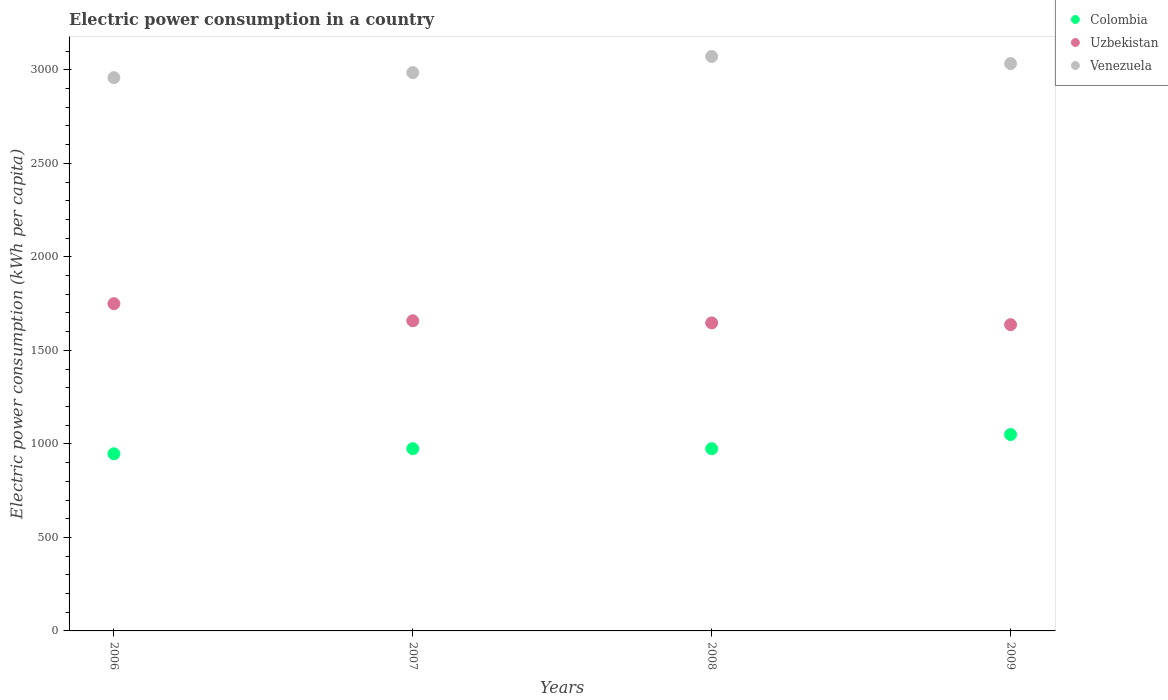How many different coloured dotlines are there?
Keep it short and to the point. 3. What is the electric power consumption in in Uzbekistan in 2009?
Make the answer very short. 1637.57. Across all years, what is the maximum electric power consumption in in Uzbekistan?
Provide a succinct answer. 1749.76. Across all years, what is the minimum electric power consumption in in Venezuela?
Keep it short and to the point. 2958.43. In which year was the electric power consumption in in Uzbekistan maximum?
Make the answer very short. 2006. What is the total electric power consumption in in Uzbekistan in the graph?
Ensure brevity in your answer.  6692.7. What is the difference between the electric power consumption in in Venezuela in 2007 and that in 2008?
Your answer should be compact. -86.19. What is the difference between the electric power consumption in in Colombia in 2007 and the electric power consumption in in Uzbekistan in 2008?
Provide a succinct answer. -672.63. What is the average electric power consumption in in Uzbekistan per year?
Provide a succinct answer. 1673.18. In the year 2007, what is the difference between the electric power consumption in in Uzbekistan and electric power consumption in in Colombia?
Provide a short and direct response. 683.98. In how many years, is the electric power consumption in in Venezuela greater than 400 kWh per capita?
Ensure brevity in your answer.  4. What is the ratio of the electric power consumption in in Colombia in 2007 to that in 2008?
Your answer should be very brief. 1. Is the difference between the electric power consumption in in Uzbekistan in 2006 and 2008 greater than the difference between the electric power consumption in in Colombia in 2006 and 2008?
Provide a short and direct response. Yes. What is the difference between the highest and the second highest electric power consumption in in Uzbekistan?
Your answer should be compact. 91.39. What is the difference between the highest and the lowest electric power consumption in in Colombia?
Offer a very short reply. 102.85. In how many years, is the electric power consumption in in Venezuela greater than the average electric power consumption in in Venezuela taken over all years?
Offer a very short reply. 2. Does the electric power consumption in in Uzbekistan monotonically increase over the years?
Offer a very short reply. No. Is the electric power consumption in in Uzbekistan strictly less than the electric power consumption in in Venezuela over the years?
Offer a very short reply. Yes. How many dotlines are there?
Make the answer very short. 3. What is the difference between two consecutive major ticks on the Y-axis?
Keep it short and to the point. 500. Are the values on the major ticks of Y-axis written in scientific E-notation?
Provide a succinct answer. No. Does the graph contain grids?
Offer a very short reply. No. Where does the legend appear in the graph?
Keep it short and to the point. Top right. What is the title of the graph?
Keep it short and to the point. Electric power consumption in a country. What is the label or title of the X-axis?
Offer a terse response. Years. What is the label or title of the Y-axis?
Provide a short and direct response. Electric power consumption (kWh per capita). What is the Electric power consumption (kWh per capita) of Colombia in 2006?
Your answer should be very brief. 947.13. What is the Electric power consumption (kWh per capita) of Uzbekistan in 2006?
Offer a very short reply. 1749.76. What is the Electric power consumption (kWh per capita) of Venezuela in 2006?
Offer a terse response. 2958.43. What is the Electric power consumption (kWh per capita) of Colombia in 2007?
Provide a short and direct response. 974.39. What is the Electric power consumption (kWh per capita) in Uzbekistan in 2007?
Provide a succinct answer. 1658.37. What is the Electric power consumption (kWh per capita) in Venezuela in 2007?
Give a very brief answer. 2985.62. What is the Electric power consumption (kWh per capita) in Colombia in 2008?
Provide a succinct answer. 974.22. What is the Electric power consumption (kWh per capita) of Uzbekistan in 2008?
Ensure brevity in your answer.  1647.01. What is the Electric power consumption (kWh per capita) of Venezuela in 2008?
Offer a very short reply. 3071.8. What is the Electric power consumption (kWh per capita) of Colombia in 2009?
Make the answer very short. 1049.98. What is the Electric power consumption (kWh per capita) of Uzbekistan in 2009?
Your response must be concise. 1637.57. What is the Electric power consumption (kWh per capita) in Venezuela in 2009?
Make the answer very short. 3033.87. Across all years, what is the maximum Electric power consumption (kWh per capita) in Colombia?
Give a very brief answer. 1049.98. Across all years, what is the maximum Electric power consumption (kWh per capita) of Uzbekistan?
Your answer should be compact. 1749.76. Across all years, what is the maximum Electric power consumption (kWh per capita) in Venezuela?
Your answer should be compact. 3071.8. Across all years, what is the minimum Electric power consumption (kWh per capita) in Colombia?
Your answer should be compact. 947.13. Across all years, what is the minimum Electric power consumption (kWh per capita) in Uzbekistan?
Provide a short and direct response. 1637.57. Across all years, what is the minimum Electric power consumption (kWh per capita) of Venezuela?
Provide a succinct answer. 2958.43. What is the total Electric power consumption (kWh per capita) of Colombia in the graph?
Your answer should be compact. 3945.71. What is the total Electric power consumption (kWh per capita) of Uzbekistan in the graph?
Ensure brevity in your answer.  6692.7. What is the total Electric power consumption (kWh per capita) in Venezuela in the graph?
Your response must be concise. 1.20e+04. What is the difference between the Electric power consumption (kWh per capita) in Colombia in 2006 and that in 2007?
Ensure brevity in your answer.  -27.26. What is the difference between the Electric power consumption (kWh per capita) in Uzbekistan in 2006 and that in 2007?
Ensure brevity in your answer.  91.39. What is the difference between the Electric power consumption (kWh per capita) in Venezuela in 2006 and that in 2007?
Provide a short and direct response. -27.19. What is the difference between the Electric power consumption (kWh per capita) in Colombia in 2006 and that in 2008?
Provide a short and direct response. -27.09. What is the difference between the Electric power consumption (kWh per capita) of Uzbekistan in 2006 and that in 2008?
Your answer should be very brief. 102.75. What is the difference between the Electric power consumption (kWh per capita) in Venezuela in 2006 and that in 2008?
Your answer should be compact. -113.38. What is the difference between the Electric power consumption (kWh per capita) in Colombia in 2006 and that in 2009?
Offer a terse response. -102.85. What is the difference between the Electric power consumption (kWh per capita) of Uzbekistan in 2006 and that in 2009?
Give a very brief answer. 112.19. What is the difference between the Electric power consumption (kWh per capita) in Venezuela in 2006 and that in 2009?
Ensure brevity in your answer.  -75.44. What is the difference between the Electric power consumption (kWh per capita) of Colombia in 2007 and that in 2008?
Offer a terse response. 0.17. What is the difference between the Electric power consumption (kWh per capita) of Uzbekistan in 2007 and that in 2008?
Give a very brief answer. 11.36. What is the difference between the Electric power consumption (kWh per capita) of Venezuela in 2007 and that in 2008?
Provide a short and direct response. -86.19. What is the difference between the Electric power consumption (kWh per capita) in Colombia in 2007 and that in 2009?
Your answer should be very brief. -75.59. What is the difference between the Electric power consumption (kWh per capita) in Uzbekistan in 2007 and that in 2009?
Keep it short and to the point. 20.8. What is the difference between the Electric power consumption (kWh per capita) of Venezuela in 2007 and that in 2009?
Provide a succinct answer. -48.25. What is the difference between the Electric power consumption (kWh per capita) of Colombia in 2008 and that in 2009?
Offer a terse response. -75.76. What is the difference between the Electric power consumption (kWh per capita) in Uzbekistan in 2008 and that in 2009?
Your response must be concise. 9.44. What is the difference between the Electric power consumption (kWh per capita) of Venezuela in 2008 and that in 2009?
Offer a very short reply. 37.94. What is the difference between the Electric power consumption (kWh per capita) in Colombia in 2006 and the Electric power consumption (kWh per capita) in Uzbekistan in 2007?
Keep it short and to the point. -711.24. What is the difference between the Electric power consumption (kWh per capita) of Colombia in 2006 and the Electric power consumption (kWh per capita) of Venezuela in 2007?
Your answer should be very brief. -2038.49. What is the difference between the Electric power consumption (kWh per capita) in Uzbekistan in 2006 and the Electric power consumption (kWh per capita) in Venezuela in 2007?
Give a very brief answer. -1235.86. What is the difference between the Electric power consumption (kWh per capita) of Colombia in 2006 and the Electric power consumption (kWh per capita) of Uzbekistan in 2008?
Provide a short and direct response. -699.88. What is the difference between the Electric power consumption (kWh per capita) in Colombia in 2006 and the Electric power consumption (kWh per capita) in Venezuela in 2008?
Give a very brief answer. -2124.68. What is the difference between the Electric power consumption (kWh per capita) of Uzbekistan in 2006 and the Electric power consumption (kWh per capita) of Venezuela in 2008?
Your answer should be compact. -1322.05. What is the difference between the Electric power consumption (kWh per capita) of Colombia in 2006 and the Electric power consumption (kWh per capita) of Uzbekistan in 2009?
Give a very brief answer. -690.44. What is the difference between the Electric power consumption (kWh per capita) of Colombia in 2006 and the Electric power consumption (kWh per capita) of Venezuela in 2009?
Your response must be concise. -2086.74. What is the difference between the Electric power consumption (kWh per capita) in Uzbekistan in 2006 and the Electric power consumption (kWh per capita) in Venezuela in 2009?
Provide a short and direct response. -1284.11. What is the difference between the Electric power consumption (kWh per capita) in Colombia in 2007 and the Electric power consumption (kWh per capita) in Uzbekistan in 2008?
Give a very brief answer. -672.63. What is the difference between the Electric power consumption (kWh per capita) of Colombia in 2007 and the Electric power consumption (kWh per capita) of Venezuela in 2008?
Your response must be concise. -2097.42. What is the difference between the Electric power consumption (kWh per capita) of Uzbekistan in 2007 and the Electric power consumption (kWh per capita) of Venezuela in 2008?
Provide a succinct answer. -1413.44. What is the difference between the Electric power consumption (kWh per capita) in Colombia in 2007 and the Electric power consumption (kWh per capita) in Uzbekistan in 2009?
Your answer should be compact. -663.18. What is the difference between the Electric power consumption (kWh per capita) in Colombia in 2007 and the Electric power consumption (kWh per capita) in Venezuela in 2009?
Your answer should be compact. -2059.48. What is the difference between the Electric power consumption (kWh per capita) in Uzbekistan in 2007 and the Electric power consumption (kWh per capita) in Venezuela in 2009?
Your answer should be very brief. -1375.5. What is the difference between the Electric power consumption (kWh per capita) in Colombia in 2008 and the Electric power consumption (kWh per capita) in Uzbekistan in 2009?
Ensure brevity in your answer.  -663.35. What is the difference between the Electric power consumption (kWh per capita) in Colombia in 2008 and the Electric power consumption (kWh per capita) in Venezuela in 2009?
Provide a succinct answer. -2059.65. What is the difference between the Electric power consumption (kWh per capita) in Uzbekistan in 2008 and the Electric power consumption (kWh per capita) in Venezuela in 2009?
Your answer should be very brief. -1386.86. What is the average Electric power consumption (kWh per capita) of Colombia per year?
Provide a short and direct response. 986.43. What is the average Electric power consumption (kWh per capita) in Uzbekistan per year?
Keep it short and to the point. 1673.18. What is the average Electric power consumption (kWh per capita) in Venezuela per year?
Offer a very short reply. 3012.43. In the year 2006, what is the difference between the Electric power consumption (kWh per capita) in Colombia and Electric power consumption (kWh per capita) in Uzbekistan?
Ensure brevity in your answer.  -802.63. In the year 2006, what is the difference between the Electric power consumption (kWh per capita) of Colombia and Electric power consumption (kWh per capita) of Venezuela?
Keep it short and to the point. -2011.3. In the year 2006, what is the difference between the Electric power consumption (kWh per capita) in Uzbekistan and Electric power consumption (kWh per capita) in Venezuela?
Your answer should be very brief. -1208.67. In the year 2007, what is the difference between the Electric power consumption (kWh per capita) in Colombia and Electric power consumption (kWh per capita) in Uzbekistan?
Ensure brevity in your answer.  -683.98. In the year 2007, what is the difference between the Electric power consumption (kWh per capita) in Colombia and Electric power consumption (kWh per capita) in Venezuela?
Your answer should be very brief. -2011.23. In the year 2007, what is the difference between the Electric power consumption (kWh per capita) in Uzbekistan and Electric power consumption (kWh per capita) in Venezuela?
Provide a short and direct response. -1327.25. In the year 2008, what is the difference between the Electric power consumption (kWh per capita) of Colombia and Electric power consumption (kWh per capita) of Uzbekistan?
Keep it short and to the point. -672.79. In the year 2008, what is the difference between the Electric power consumption (kWh per capita) in Colombia and Electric power consumption (kWh per capita) in Venezuela?
Your answer should be very brief. -2097.58. In the year 2008, what is the difference between the Electric power consumption (kWh per capita) in Uzbekistan and Electric power consumption (kWh per capita) in Venezuela?
Offer a terse response. -1424.79. In the year 2009, what is the difference between the Electric power consumption (kWh per capita) of Colombia and Electric power consumption (kWh per capita) of Uzbekistan?
Your answer should be very brief. -587.59. In the year 2009, what is the difference between the Electric power consumption (kWh per capita) in Colombia and Electric power consumption (kWh per capita) in Venezuela?
Provide a short and direct response. -1983.89. In the year 2009, what is the difference between the Electric power consumption (kWh per capita) of Uzbekistan and Electric power consumption (kWh per capita) of Venezuela?
Your response must be concise. -1396.3. What is the ratio of the Electric power consumption (kWh per capita) of Colombia in 2006 to that in 2007?
Provide a succinct answer. 0.97. What is the ratio of the Electric power consumption (kWh per capita) of Uzbekistan in 2006 to that in 2007?
Provide a short and direct response. 1.06. What is the ratio of the Electric power consumption (kWh per capita) of Venezuela in 2006 to that in 2007?
Make the answer very short. 0.99. What is the ratio of the Electric power consumption (kWh per capita) in Colombia in 2006 to that in 2008?
Offer a very short reply. 0.97. What is the ratio of the Electric power consumption (kWh per capita) of Uzbekistan in 2006 to that in 2008?
Your response must be concise. 1.06. What is the ratio of the Electric power consumption (kWh per capita) of Venezuela in 2006 to that in 2008?
Give a very brief answer. 0.96. What is the ratio of the Electric power consumption (kWh per capita) of Colombia in 2006 to that in 2009?
Offer a very short reply. 0.9. What is the ratio of the Electric power consumption (kWh per capita) of Uzbekistan in 2006 to that in 2009?
Give a very brief answer. 1.07. What is the ratio of the Electric power consumption (kWh per capita) in Venezuela in 2006 to that in 2009?
Your answer should be very brief. 0.98. What is the ratio of the Electric power consumption (kWh per capita) in Colombia in 2007 to that in 2008?
Your answer should be compact. 1. What is the ratio of the Electric power consumption (kWh per capita) in Uzbekistan in 2007 to that in 2008?
Offer a terse response. 1.01. What is the ratio of the Electric power consumption (kWh per capita) of Venezuela in 2007 to that in 2008?
Keep it short and to the point. 0.97. What is the ratio of the Electric power consumption (kWh per capita) of Colombia in 2007 to that in 2009?
Offer a terse response. 0.93. What is the ratio of the Electric power consumption (kWh per capita) in Uzbekistan in 2007 to that in 2009?
Provide a succinct answer. 1.01. What is the ratio of the Electric power consumption (kWh per capita) of Venezuela in 2007 to that in 2009?
Provide a short and direct response. 0.98. What is the ratio of the Electric power consumption (kWh per capita) in Colombia in 2008 to that in 2009?
Ensure brevity in your answer.  0.93. What is the ratio of the Electric power consumption (kWh per capita) of Venezuela in 2008 to that in 2009?
Your response must be concise. 1.01. What is the difference between the highest and the second highest Electric power consumption (kWh per capita) of Colombia?
Your answer should be compact. 75.59. What is the difference between the highest and the second highest Electric power consumption (kWh per capita) of Uzbekistan?
Ensure brevity in your answer.  91.39. What is the difference between the highest and the second highest Electric power consumption (kWh per capita) in Venezuela?
Your answer should be compact. 37.94. What is the difference between the highest and the lowest Electric power consumption (kWh per capita) in Colombia?
Keep it short and to the point. 102.85. What is the difference between the highest and the lowest Electric power consumption (kWh per capita) in Uzbekistan?
Offer a very short reply. 112.19. What is the difference between the highest and the lowest Electric power consumption (kWh per capita) of Venezuela?
Offer a terse response. 113.38. 